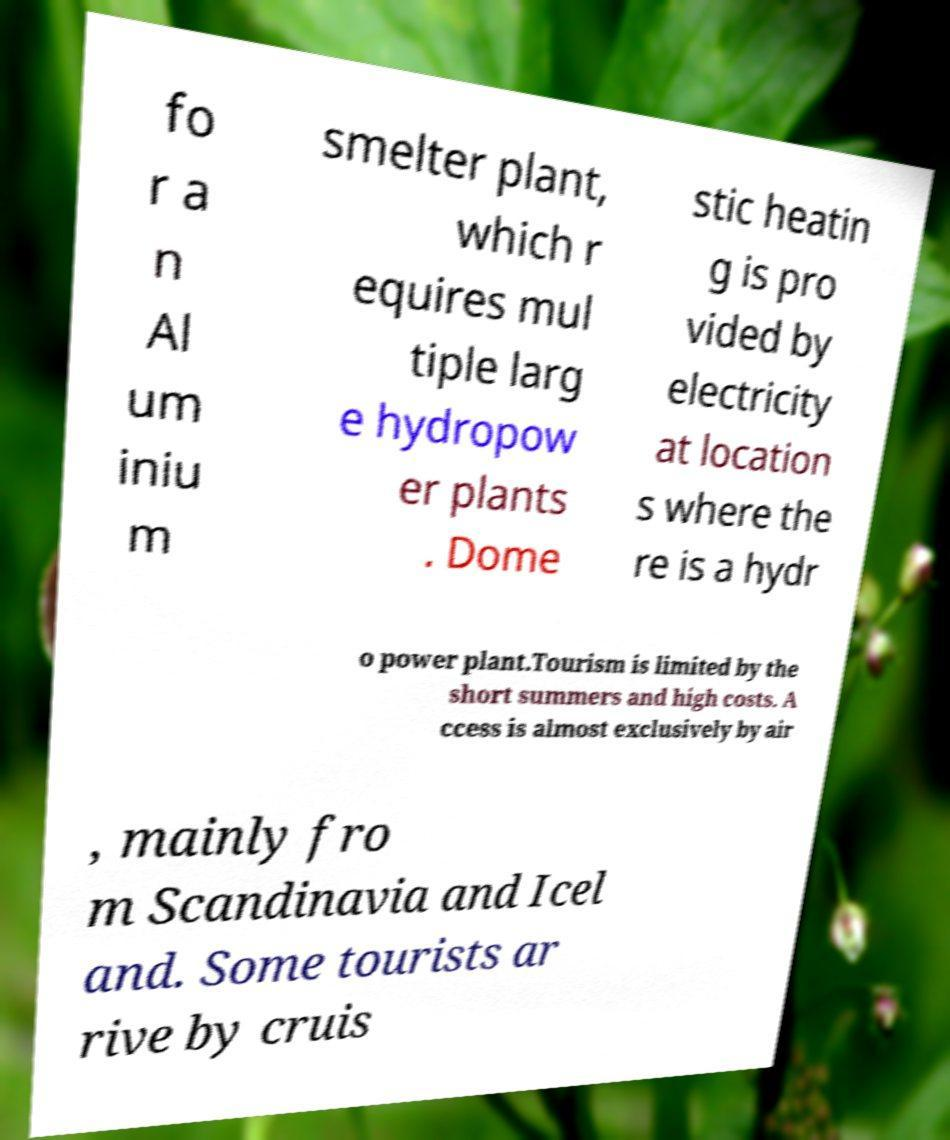Can you accurately transcribe the text from the provided image for me? fo r a n Al um iniu m smelter plant, which r equires mul tiple larg e hydropow er plants . Dome stic heatin g is pro vided by electricity at location s where the re is a hydr o power plant.Tourism is limited by the short summers and high costs. A ccess is almost exclusively by air , mainly fro m Scandinavia and Icel and. Some tourists ar rive by cruis 